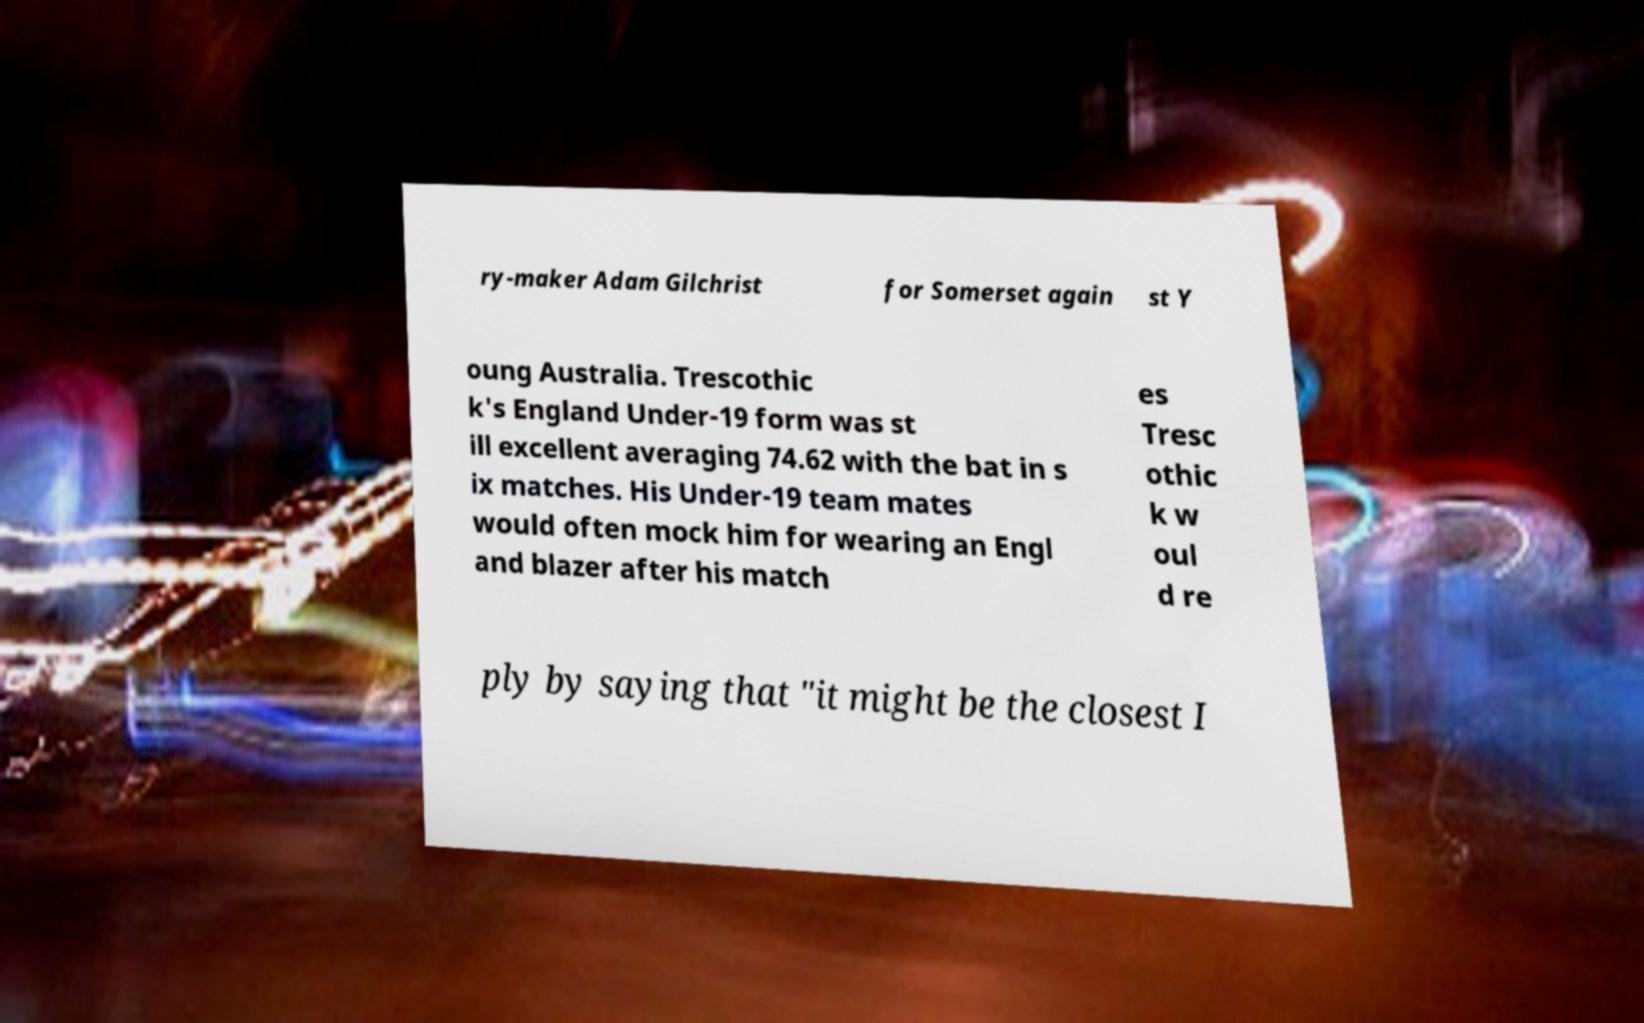Please read and relay the text visible in this image. What does it say? ry-maker Adam Gilchrist for Somerset again st Y oung Australia. Trescothic k's England Under-19 form was st ill excellent averaging 74.62 with the bat in s ix matches. His Under-19 team mates would often mock him for wearing an Engl and blazer after his match es Tresc othic k w oul d re ply by saying that "it might be the closest I 